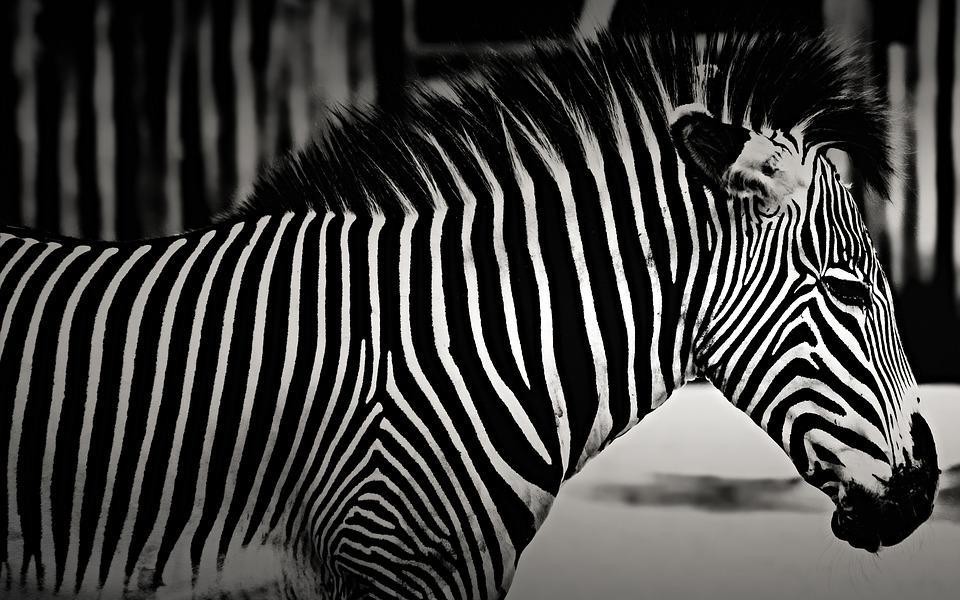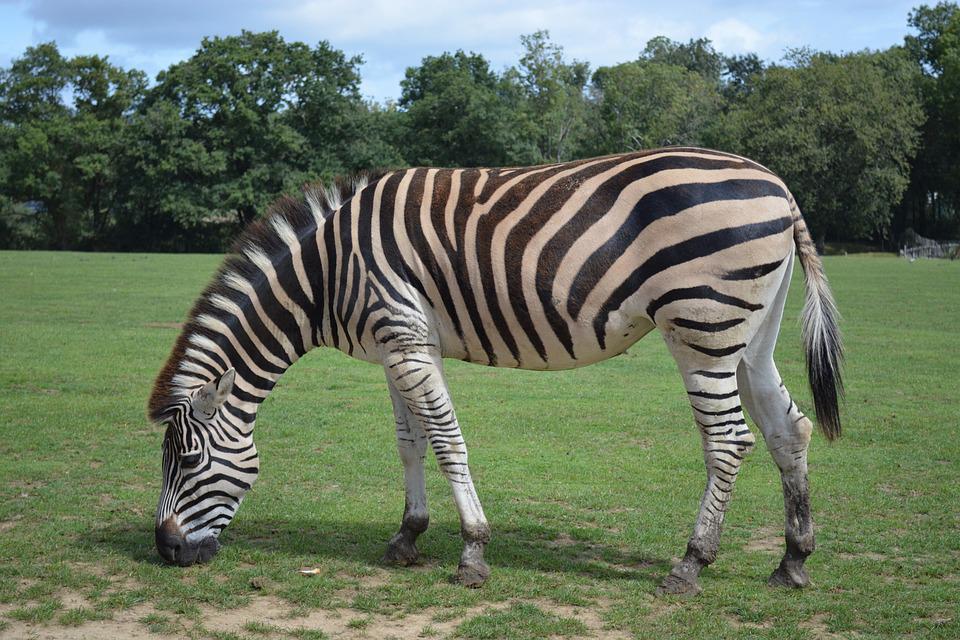The first image is the image on the left, the second image is the image on the right. Examine the images to the left and right. Is the description "One zebra is facing right." accurate? Answer yes or no. Yes. The first image is the image on the left, the second image is the image on the right. For the images displayed, is the sentence "Each image contains one zebra standing with head and body in profile, but the zebra on the right has its head bent lower." factually correct? Answer yes or no. Yes. 